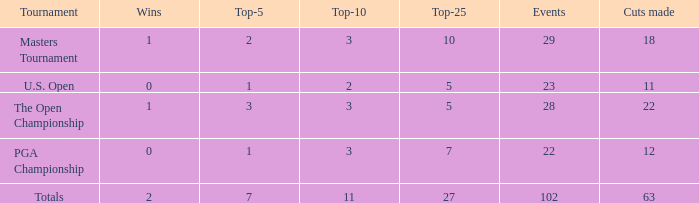How many top 10s did he have when he had fewer than 1 top 5? None. 